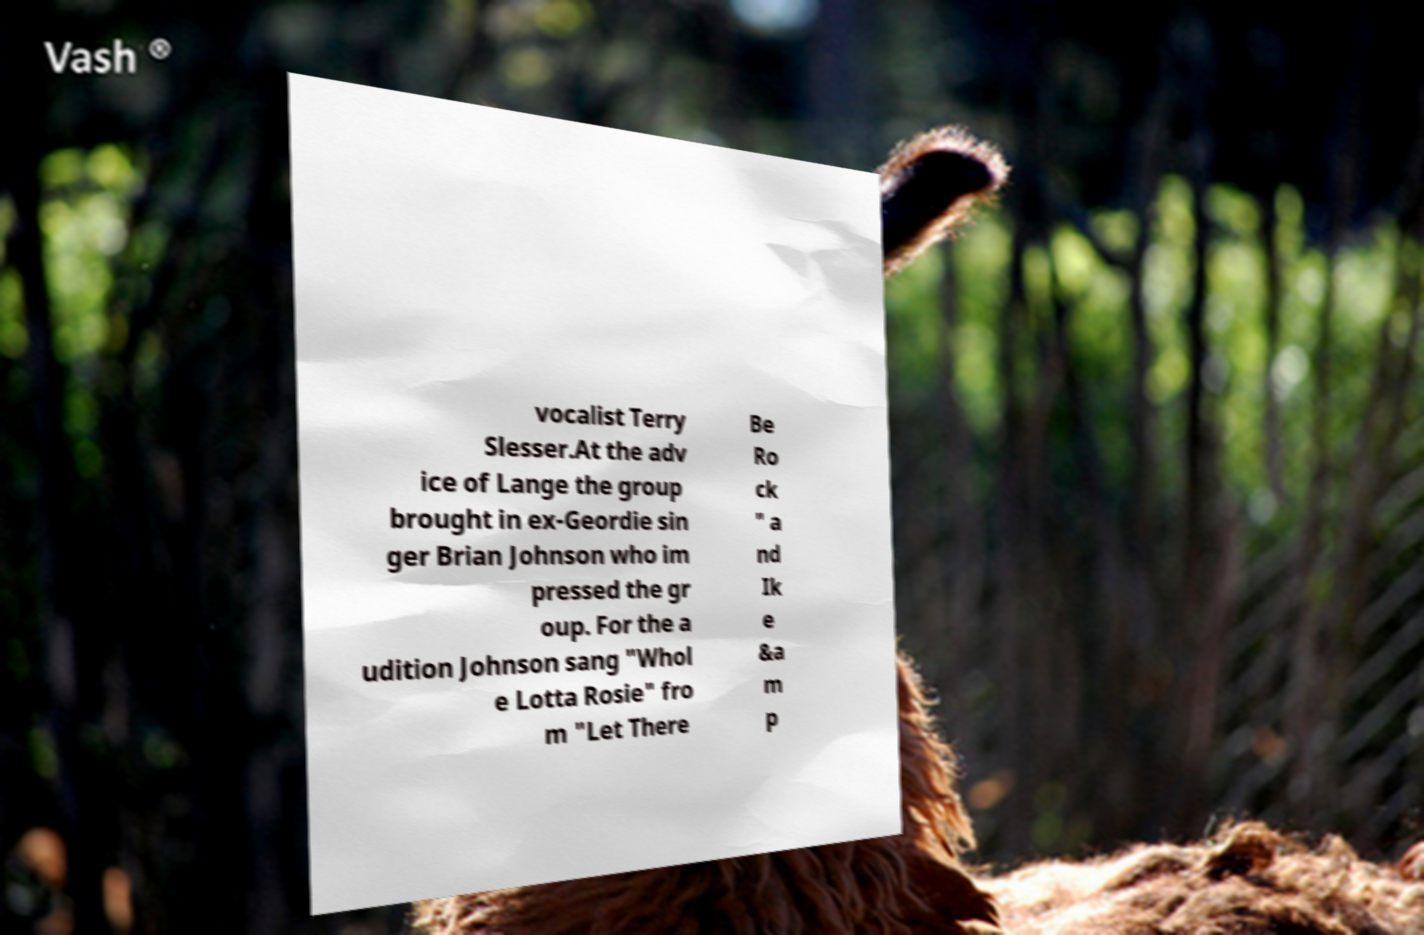Please identify and transcribe the text found in this image. vocalist Terry Slesser.At the adv ice of Lange the group brought in ex-Geordie sin ger Brian Johnson who im pressed the gr oup. For the a udition Johnson sang "Whol e Lotta Rosie" fro m "Let There Be Ro ck " a nd Ik e &a m p 